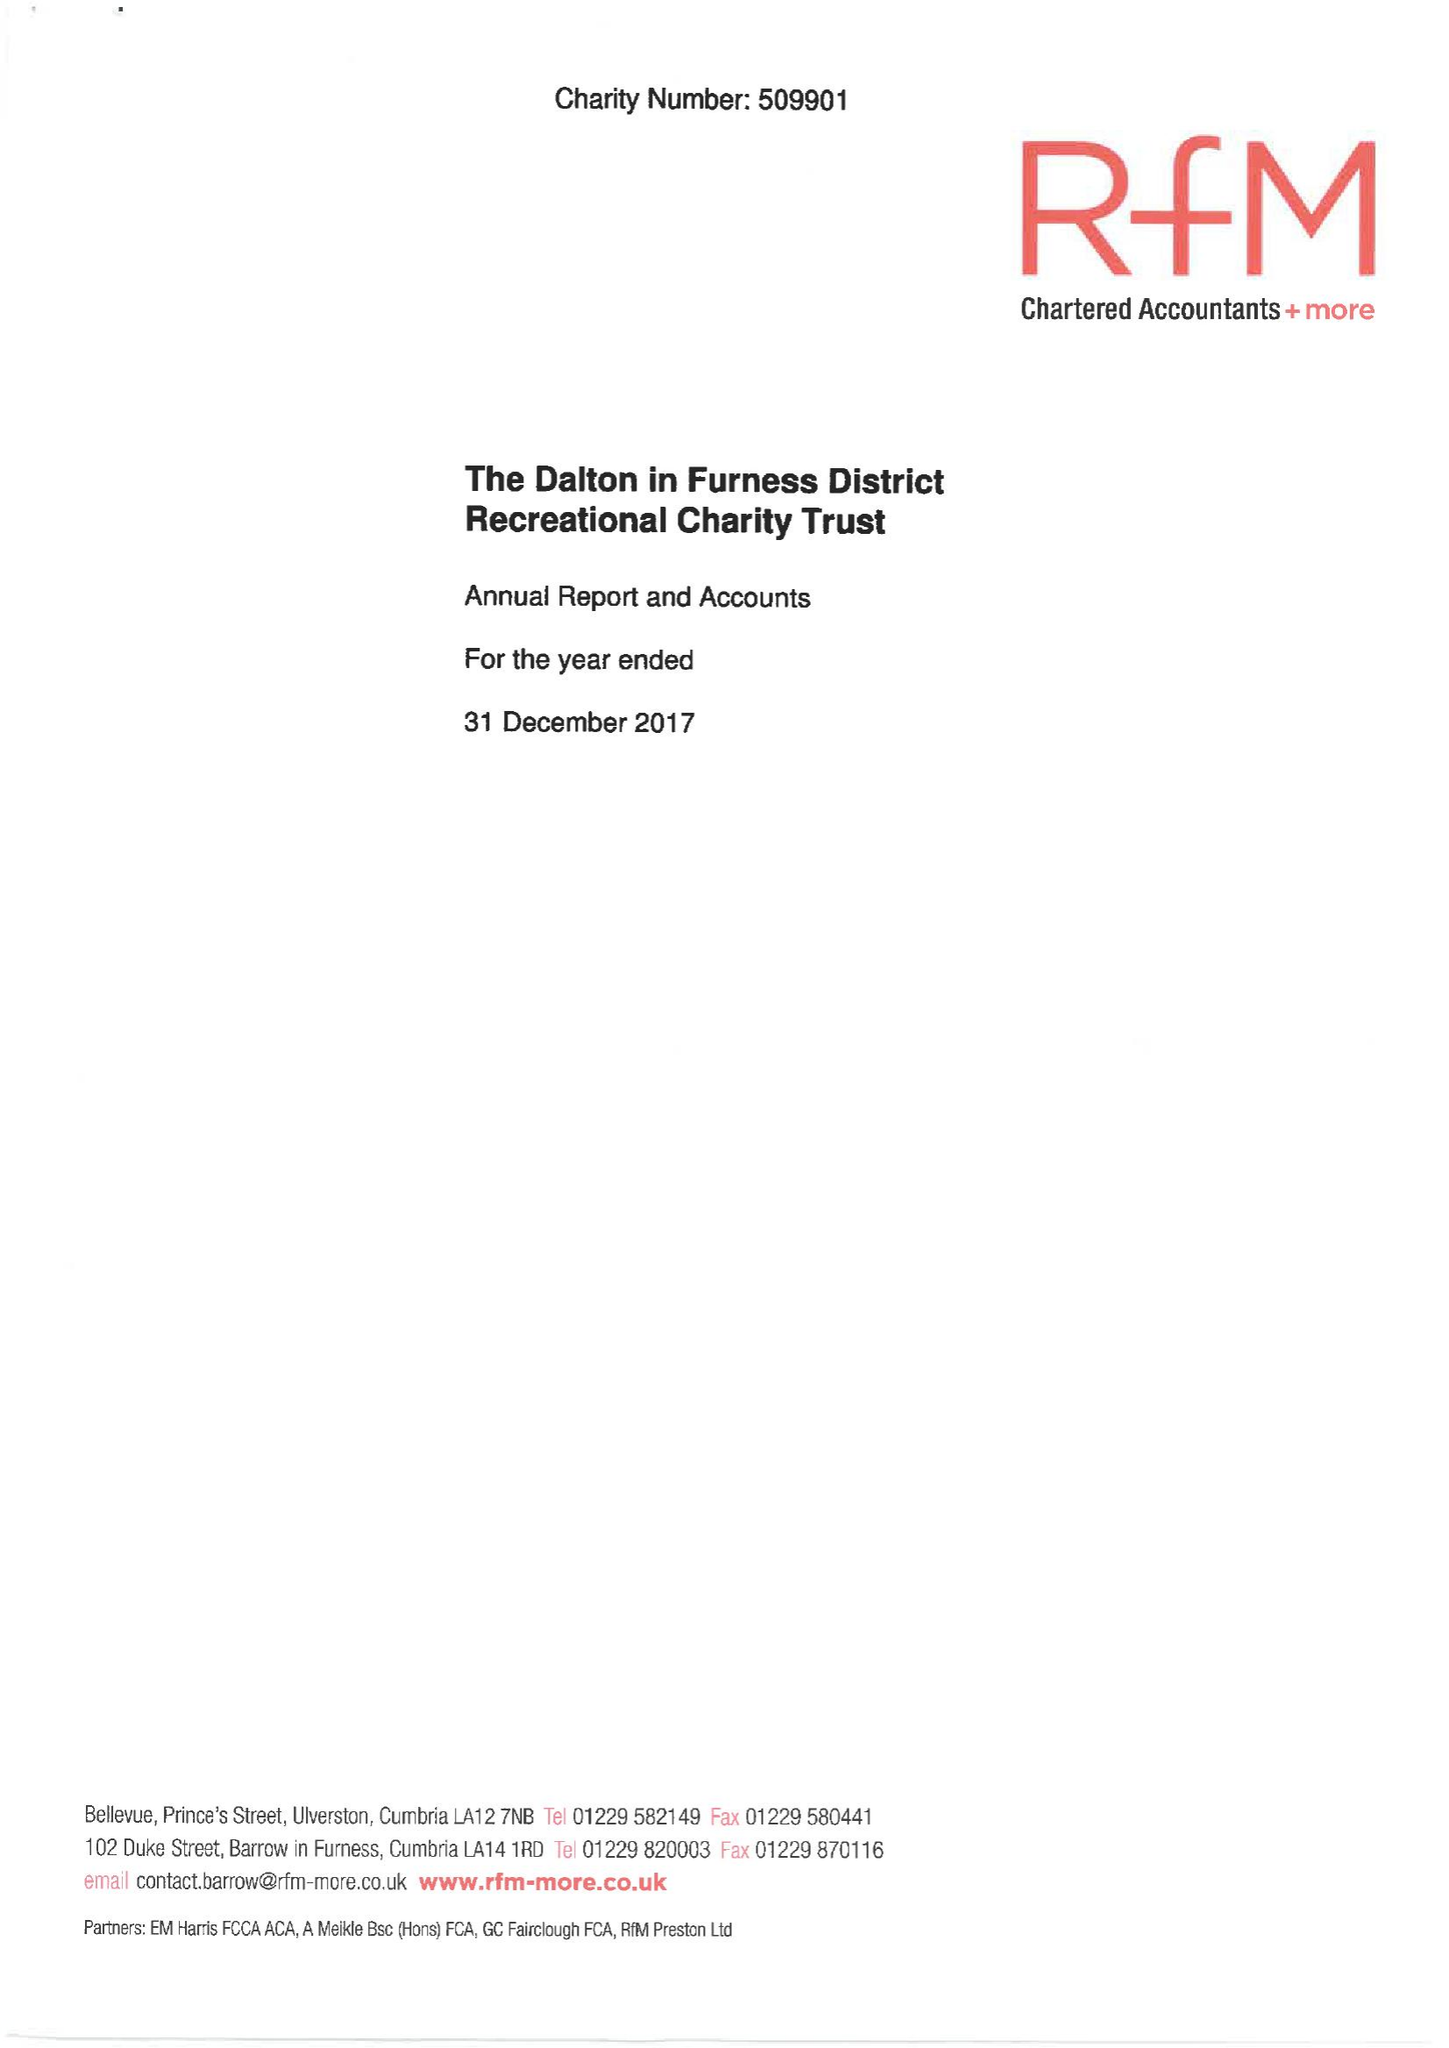What is the value for the address__street_line?
Answer the question using a single word or phrase. CHAPELS 